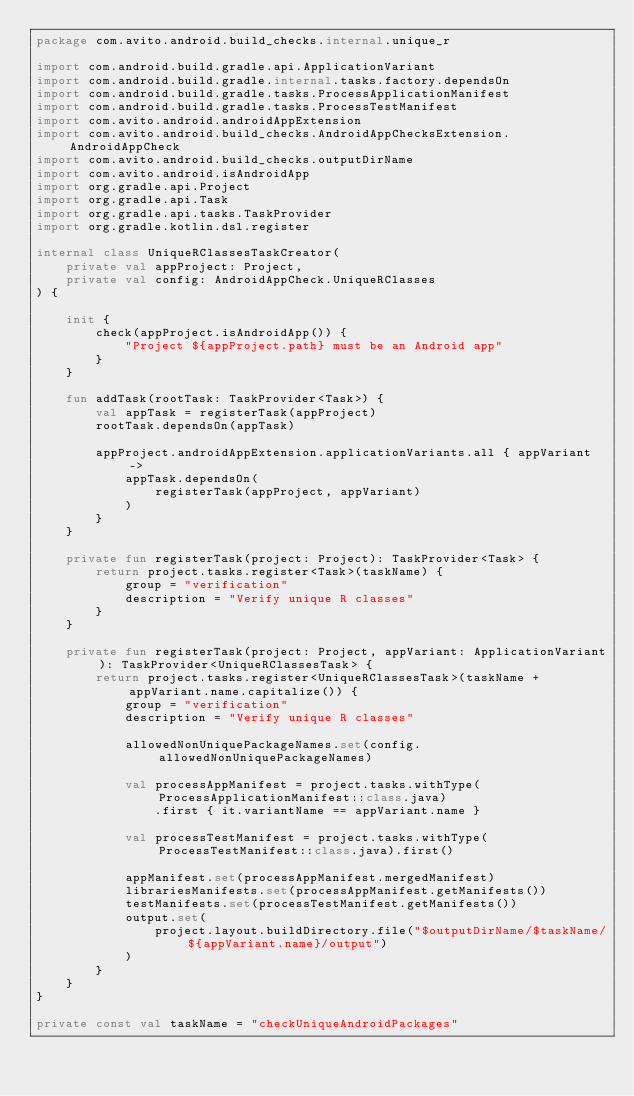Convert code to text. <code><loc_0><loc_0><loc_500><loc_500><_Kotlin_>package com.avito.android.build_checks.internal.unique_r

import com.android.build.gradle.api.ApplicationVariant
import com.android.build.gradle.internal.tasks.factory.dependsOn
import com.android.build.gradle.tasks.ProcessApplicationManifest
import com.android.build.gradle.tasks.ProcessTestManifest
import com.avito.android.androidAppExtension
import com.avito.android.build_checks.AndroidAppChecksExtension.AndroidAppCheck
import com.avito.android.build_checks.outputDirName
import com.avito.android.isAndroidApp
import org.gradle.api.Project
import org.gradle.api.Task
import org.gradle.api.tasks.TaskProvider
import org.gradle.kotlin.dsl.register

internal class UniqueRClassesTaskCreator(
    private val appProject: Project,
    private val config: AndroidAppCheck.UniqueRClasses
) {

    init {
        check(appProject.isAndroidApp()) {
            "Project ${appProject.path} must be an Android app"
        }
    }

    fun addTask(rootTask: TaskProvider<Task>) {
        val appTask = registerTask(appProject)
        rootTask.dependsOn(appTask)

        appProject.androidAppExtension.applicationVariants.all { appVariant ->
            appTask.dependsOn(
                registerTask(appProject, appVariant)
            )
        }
    }

    private fun registerTask(project: Project): TaskProvider<Task> {
        return project.tasks.register<Task>(taskName) {
            group = "verification"
            description = "Verify unique R classes"
        }
    }

    private fun registerTask(project: Project, appVariant: ApplicationVariant): TaskProvider<UniqueRClassesTask> {
        return project.tasks.register<UniqueRClassesTask>(taskName + appVariant.name.capitalize()) {
            group = "verification"
            description = "Verify unique R classes"

            allowedNonUniquePackageNames.set(config.allowedNonUniquePackageNames)

            val processAppManifest = project.tasks.withType(ProcessApplicationManifest::class.java)
                .first { it.variantName == appVariant.name }

            val processTestManifest = project.tasks.withType(ProcessTestManifest::class.java).first()

            appManifest.set(processAppManifest.mergedManifest)
            librariesManifests.set(processAppManifest.getManifests())
            testManifests.set(processTestManifest.getManifests())
            output.set(
                project.layout.buildDirectory.file("$outputDirName/$taskName/${appVariant.name}/output")
            )
        }
    }
}

private const val taskName = "checkUniqueAndroidPackages"
</code> 